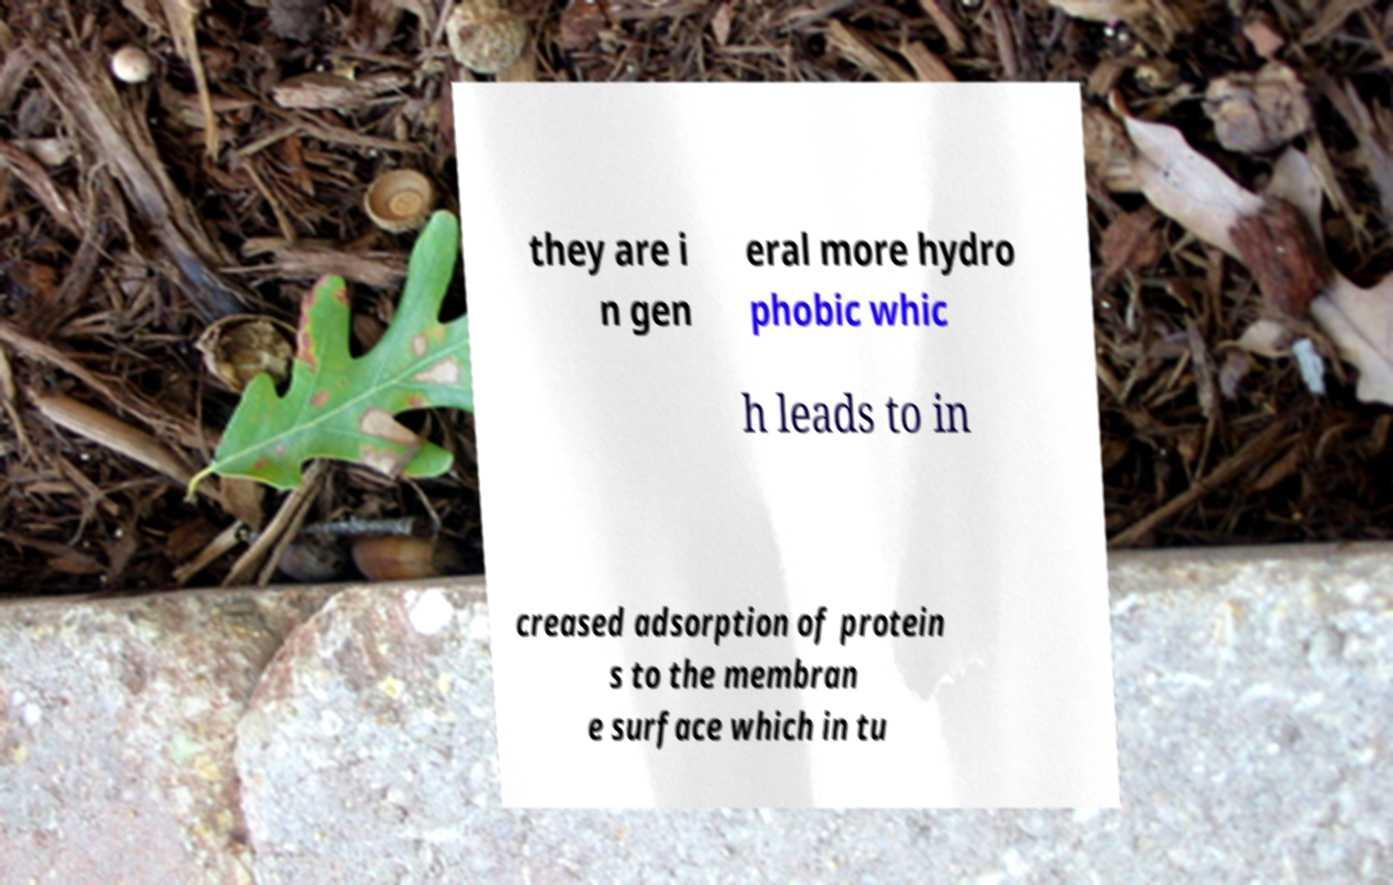Please read and relay the text visible in this image. What does it say? they are i n gen eral more hydro phobic whic h leads to in creased adsorption of protein s to the membran e surface which in tu 